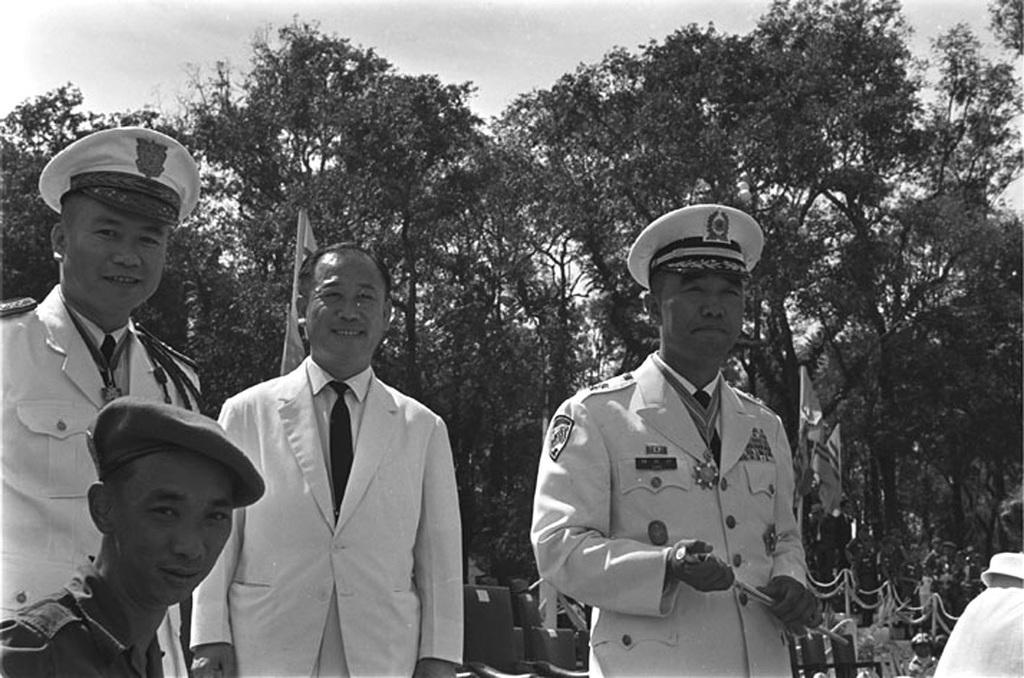In one or two sentences, can you explain what this image depicts? In this image I can see the black and white picture in which I can see few persons wearing white colored dresses are standing. In the background I can see few chairs, few persons, few flags, few trees and the sky. 